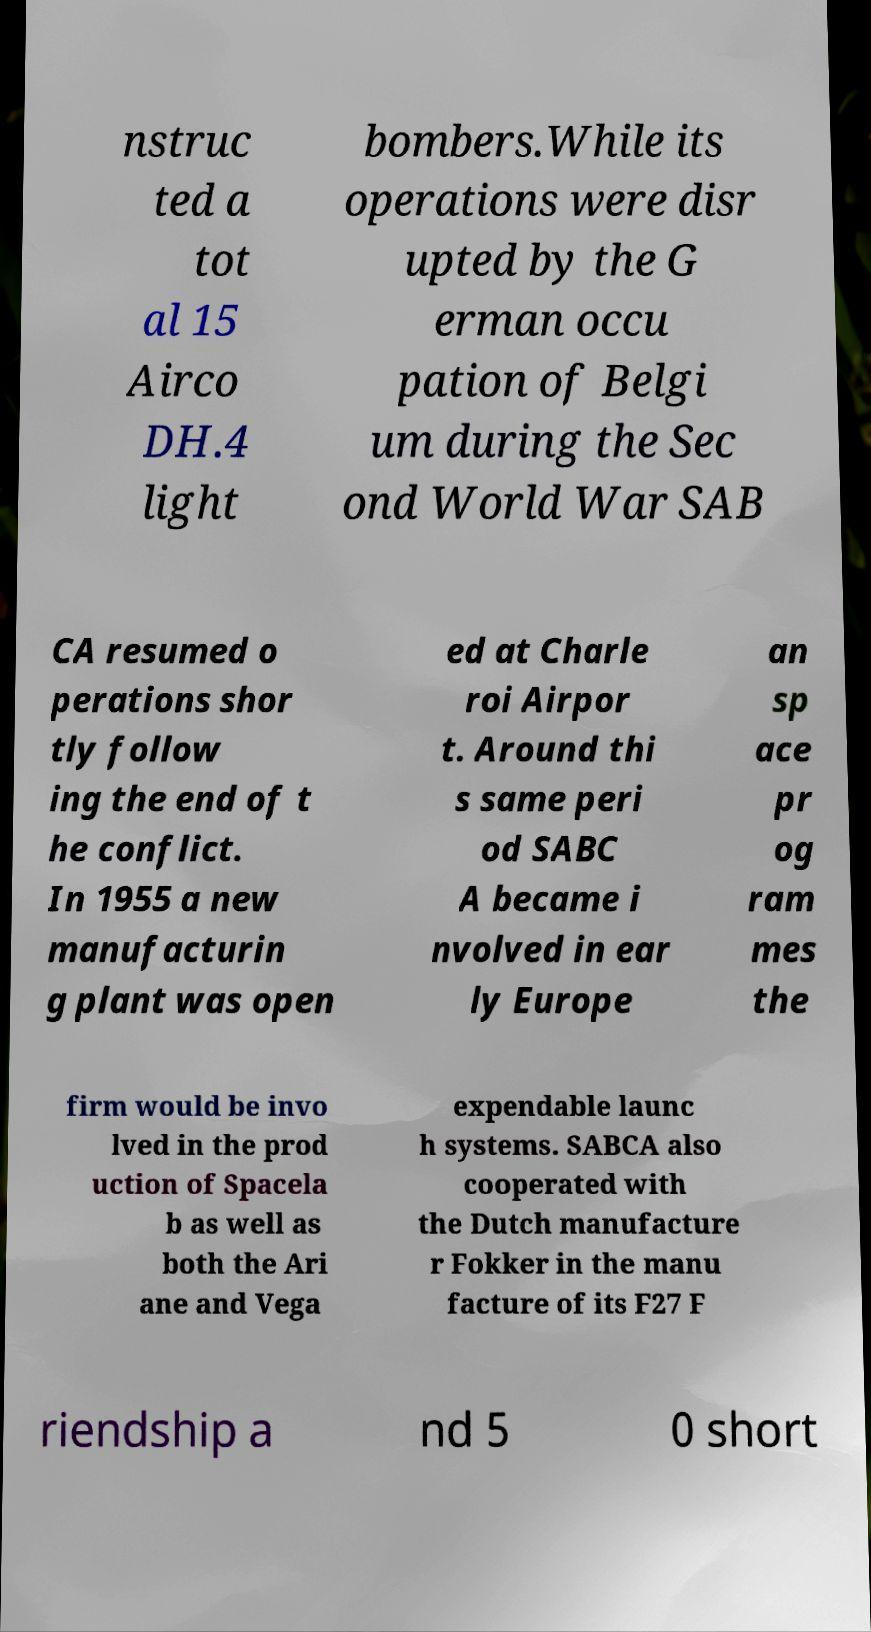Can you read and provide the text displayed in the image?This photo seems to have some interesting text. Can you extract and type it out for me? nstruc ted a tot al 15 Airco DH.4 light bombers.While its operations were disr upted by the G erman occu pation of Belgi um during the Sec ond World War SAB CA resumed o perations shor tly follow ing the end of t he conflict. In 1955 a new manufacturin g plant was open ed at Charle roi Airpor t. Around thi s same peri od SABC A became i nvolved in ear ly Europe an sp ace pr og ram mes the firm would be invo lved in the prod uction of Spacela b as well as both the Ari ane and Vega expendable launc h systems. SABCA also cooperated with the Dutch manufacture r Fokker in the manu facture of its F27 F riendship a nd 5 0 short 